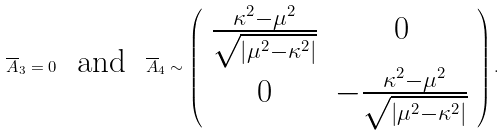Convert formula to latex. <formula><loc_0><loc_0><loc_500><loc_500>\overline { A } _ { 3 } = 0 \text { \ and \ } \overline { A } _ { 4 } \sim \left ( \begin{array} { c c } \frac { \kappa ^ { 2 } - \mu ^ { 2 } } { \sqrt { \left | \mu ^ { 2 } - \kappa ^ { 2 } \right | } } & 0 \\ 0 & - \frac { \kappa ^ { 2 } - \mu ^ { 2 } } { \sqrt { \left | \mu ^ { 2 } - \kappa ^ { 2 } \right | } } \end{array} \right ) .</formula> 